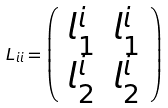Convert formula to latex. <formula><loc_0><loc_0><loc_500><loc_500>L _ { i i } = \left ( \begin{array} { c c } l _ { 1 } ^ { i } & l _ { 1 } ^ { i } \\ l _ { 2 } ^ { i } & l _ { 2 } ^ { i } \end{array} \right )</formula> 